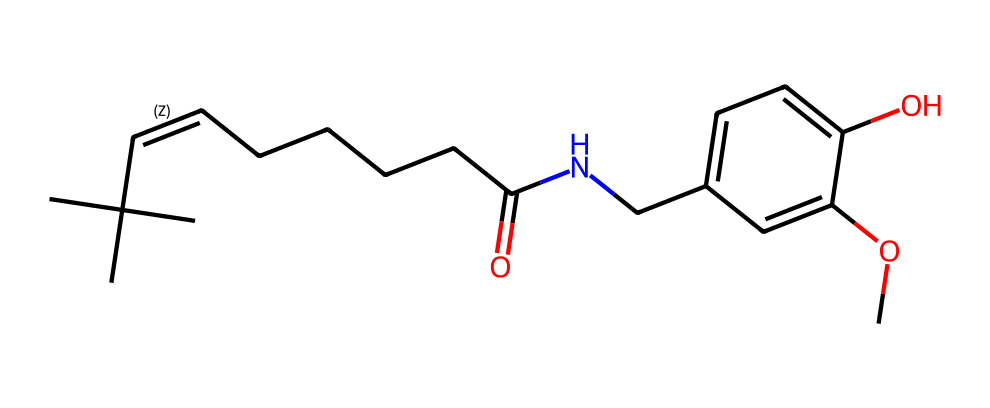what is the molecular formula of capsaicin? To determine the molecular formula, count the number of each type of atom present in the structure: there are 18 carbon (C) atoms, 27 hydrogen (H) atoms, and 1 nitrogen (N) atom, and 3 oxygen (O) atoms. Therefore, the molecular formula is C18H27NO3.
Answer: C18H27NO3 how many oxygen atoms are in the structure? By examining the structure and counting the oxygen (O) atoms, there are a total of 3 oxygen atoms present.
Answer: 3 does capsaicin contain a double bond? In the given structure, there is a carbon-carbon double bond present between two carbon atoms in the chain, indicated by the presence of '='.
Answer: yes what is the function of the amide group in capsaicin? The amide group is represented by the nitrogen atom followed by a carbonyl (C=O). This group contributes to the overall properties of the molecule, such as its flavor and interaction with receptors in the body.
Answer: flavor interaction how many rings are present in the chemical structure of capsaicin? Looking at the structure, there is only one benzene ring present in the compound, as indicated by the cyclic arrangement of carbon atoms.
Answer: 1 how does the long hydrocarbon chain affect the properties of capsaicin? The long hydrocarbon chain increases the lipophilicity (fat solubility) of capsaicin, allowing it to better interact with cell membranes and enhancing its pungency.
Answer: increases lipophilicity what type of chemical bond connects carbon and oxygen in the hydroxyl group? The carbon and oxygen in the hydroxyl (–OH) group are connected by a covalent bond. In this bond, a pair of electrons is shared between the carbon and oxygen atoms.
Answer: covalent bond 